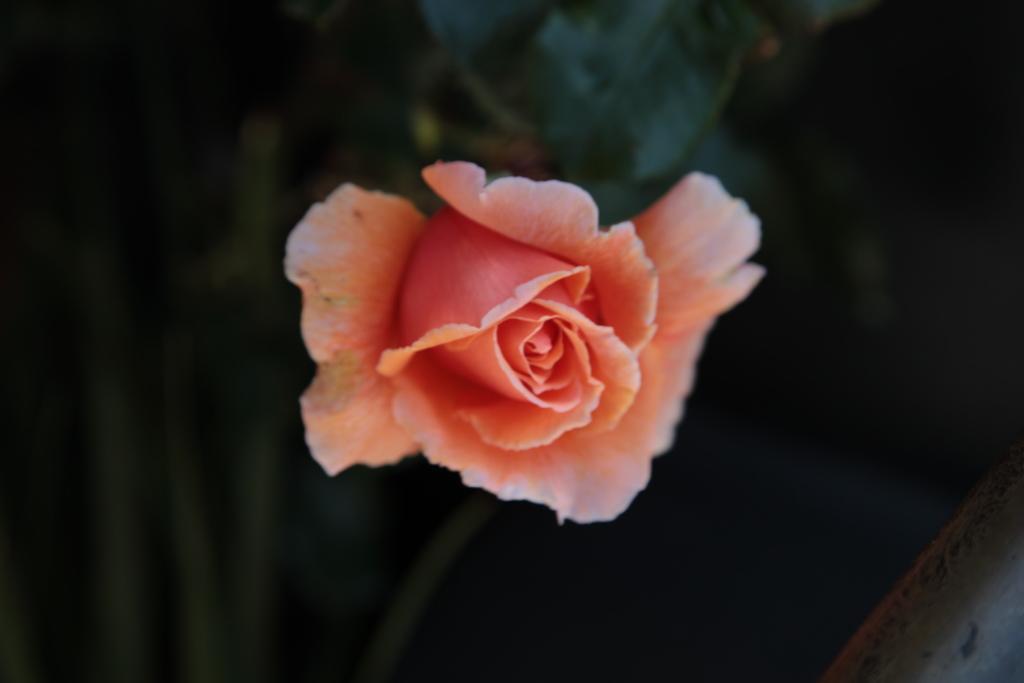Describe this image in one or two sentences. In this image we can see a rose flower. 